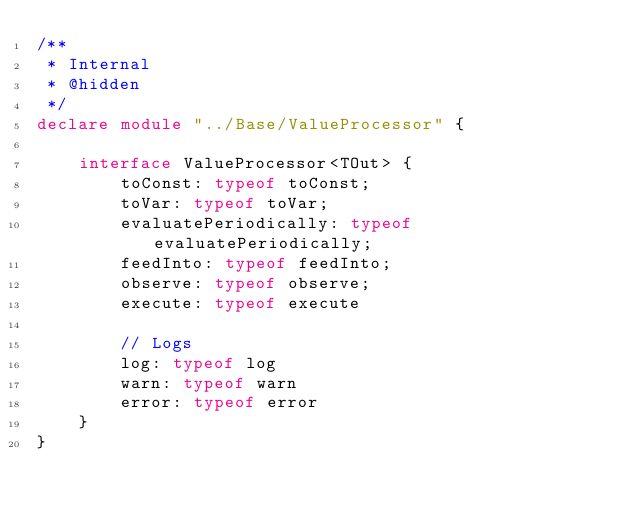<code> <loc_0><loc_0><loc_500><loc_500><_TypeScript_>/**
 * Internal
 * @hidden
 */
declare module "../Base/ValueProcessor" {

	interface ValueProcessor<TOut> {
		toConst: typeof toConst;
		toVar: typeof toVar;
		evaluatePeriodically: typeof evaluatePeriodically;
		feedInto: typeof feedInto;
		observe: typeof observe;
		execute: typeof execute

		// Logs
		log: typeof log
		warn: typeof warn
		error: typeof error
	}
}</code> 